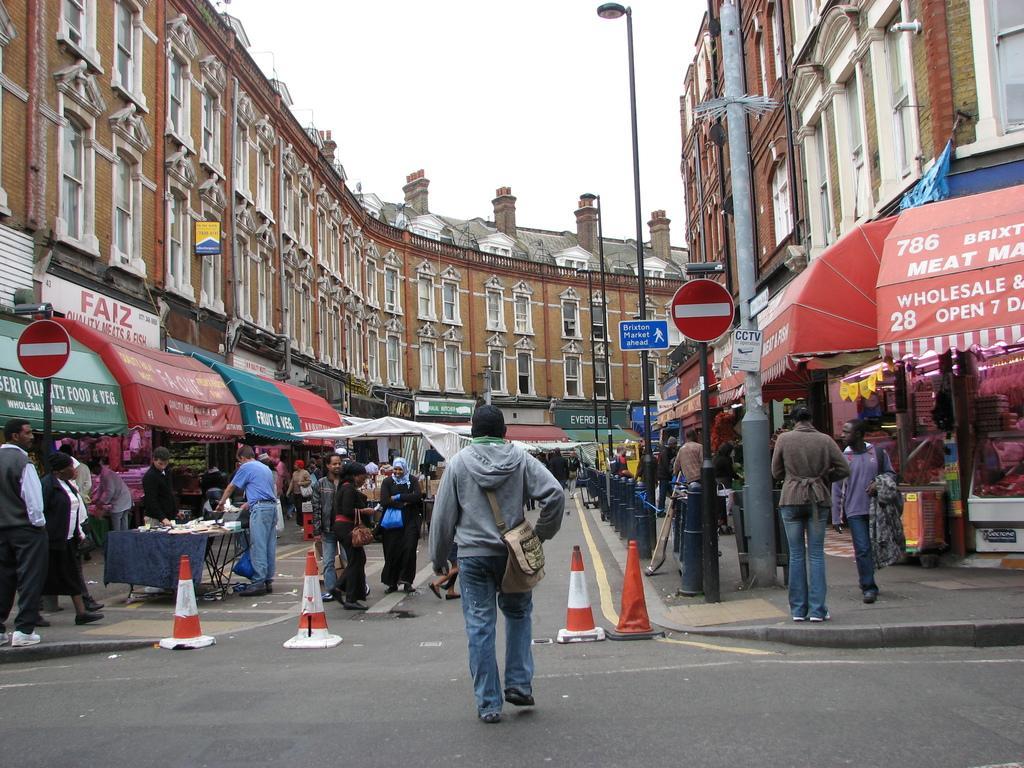Can you describe this image briefly? In this image I can see group of people, some are standing and some are walking and I can also see few poles and I can see few stalls, banners in multicolor. Background I can see few light poles, buildings in brown and cream color. 